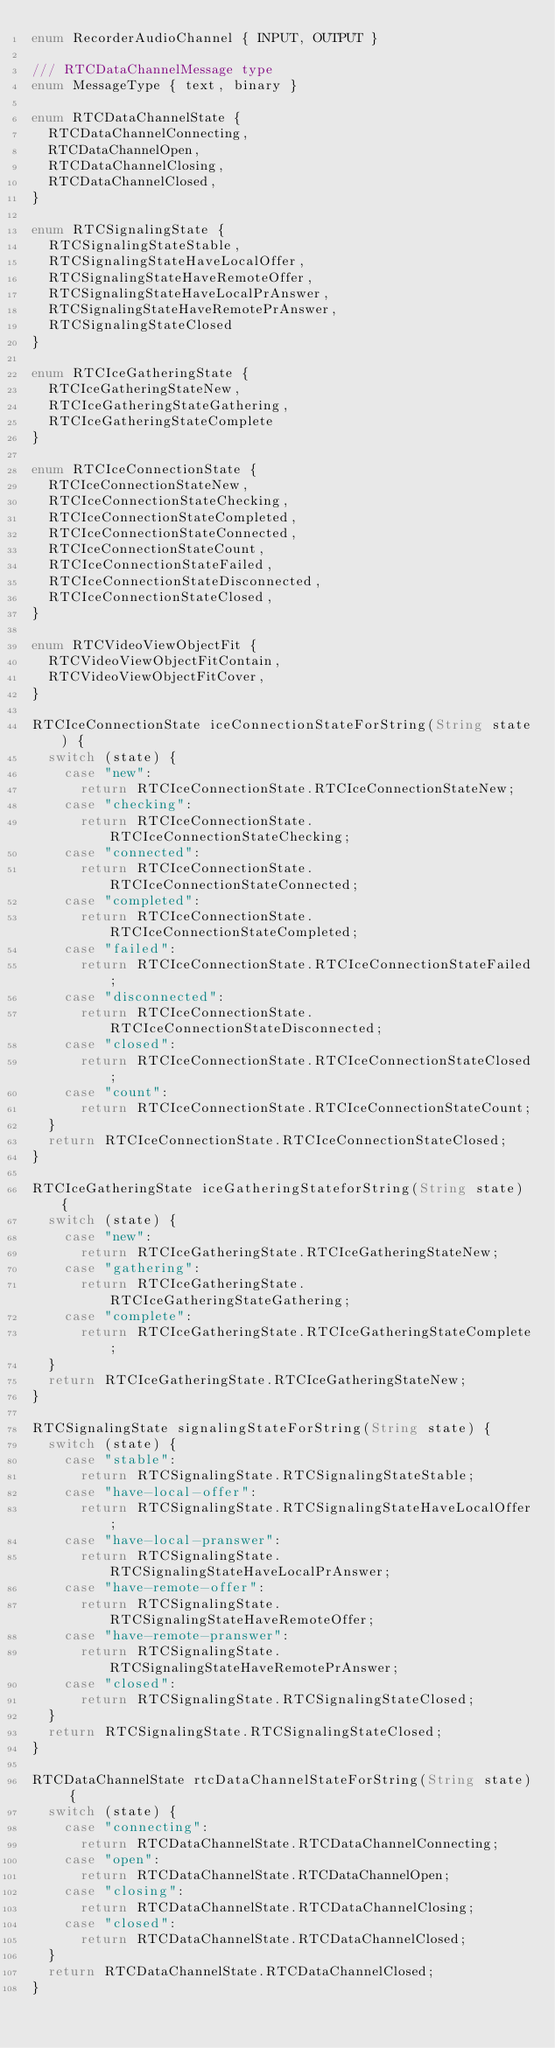Convert code to text. <code><loc_0><loc_0><loc_500><loc_500><_Dart_>enum RecorderAudioChannel { INPUT, OUTPUT }

/// RTCDataChannelMessage type
enum MessageType { text, binary }

enum RTCDataChannelState {
  RTCDataChannelConnecting,
  RTCDataChannelOpen,
  RTCDataChannelClosing,
  RTCDataChannelClosed,
}

enum RTCSignalingState {
  RTCSignalingStateStable,
  RTCSignalingStateHaveLocalOffer,
  RTCSignalingStateHaveRemoteOffer,
  RTCSignalingStateHaveLocalPrAnswer,
  RTCSignalingStateHaveRemotePrAnswer,
  RTCSignalingStateClosed
}

enum RTCIceGatheringState {
  RTCIceGatheringStateNew,
  RTCIceGatheringStateGathering,
  RTCIceGatheringStateComplete
}

enum RTCIceConnectionState {
  RTCIceConnectionStateNew,
  RTCIceConnectionStateChecking,
  RTCIceConnectionStateCompleted,
  RTCIceConnectionStateConnected,
  RTCIceConnectionStateCount,
  RTCIceConnectionStateFailed,
  RTCIceConnectionStateDisconnected,
  RTCIceConnectionStateClosed,
}

enum RTCVideoViewObjectFit {
  RTCVideoViewObjectFitContain,
  RTCVideoViewObjectFitCover,
}

RTCIceConnectionState iceConnectionStateForString(String state) {
  switch (state) {
    case "new":
      return RTCIceConnectionState.RTCIceConnectionStateNew;
    case "checking":
      return RTCIceConnectionState.RTCIceConnectionStateChecking;
    case "connected":
      return RTCIceConnectionState.RTCIceConnectionStateConnected;
    case "completed":
      return RTCIceConnectionState.RTCIceConnectionStateCompleted;
    case "failed":
      return RTCIceConnectionState.RTCIceConnectionStateFailed;
    case "disconnected":
      return RTCIceConnectionState.RTCIceConnectionStateDisconnected;
    case "closed":
      return RTCIceConnectionState.RTCIceConnectionStateClosed;
    case "count":
      return RTCIceConnectionState.RTCIceConnectionStateCount;
  }
  return RTCIceConnectionState.RTCIceConnectionStateClosed;
}

RTCIceGatheringState iceGatheringStateforString(String state) {
  switch (state) {
    case "new":
      return RTCIceGatheringState.RTCIceGatheringStateNew;
    case "gathering":
      return RTCIceGatheringState.RTCIceGatheringStateGathering;
    case "complete":
      return RTCIceGatheringState.RTCIceGatheringStateComplete;
  }
  return RTCIceGatheringState.RTCIceGatheringStateNew;
}

RTCSignalingState signalingStateForString(String state) {
  switch (state) {
    case "stable":
      return RTCSignalingState.RTCSignalingStateStable;
    case "have-local-offer":
      return RTCSignalingState.RTCSignalingStateHaveLocalOffer;
    case "have-local-pranswer":
      return RTCSignalingState.RTCSignalingStateHaveLocalPrAnswer;
    case "have-remote-offer":
      return RTCSignalingState.RTCSignalingStateHaveRemoteOffer;
    case "have-remote-pranswer":
      return RTCSignalingState.RTCSignalingStateHaveRemotePrAnswer;
    case "closed":
      return RTCSignalingState.RTCSignalingStateClosed;
  }
  return RTCSignalingState.RTCSignalingStateClosed;
}

RTCDataChannelState rtcDataChannelStateForString(String state) {
  switch (state) {
    case "connecting":
      return RTCDataChannelState.RTCDataChannelConnecting;
    case "open":
      return RTCDataChannelState.RTCDataChannelOpen;
    case "closing":
      return RTCDataChannelState.RTCDataChannelClosing;
    case "closed":
      return RTCDataChannelState.RTCDataChannelClosed;
  }
  return RTCDataChannelState.RTCDataChannelClosed;
}

</code> 